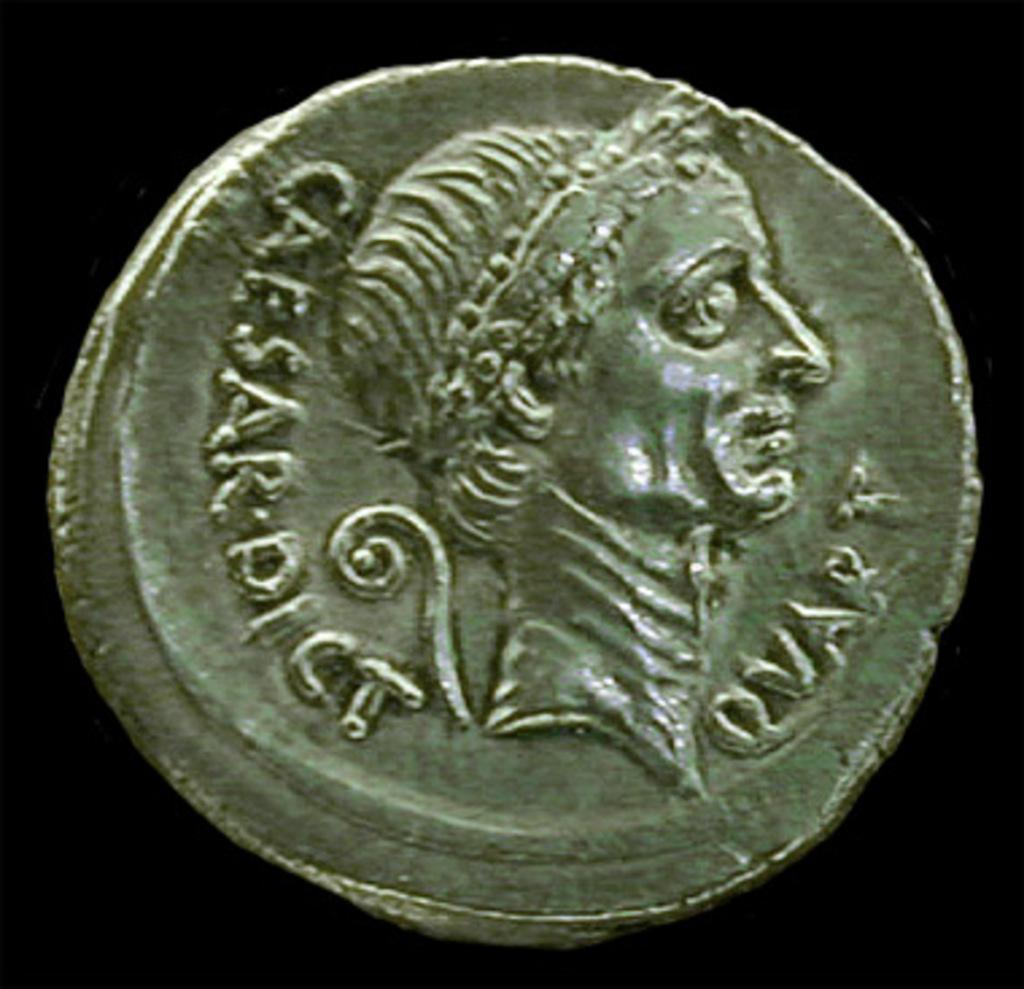<image>
Create a compact narrative representing the image presented. An antique coin that has the writing Caesar on it. 